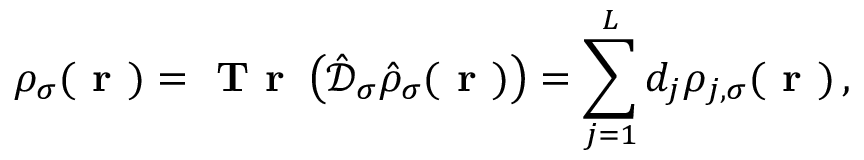<formula> <loc_0><loc_0><loc_500><loc_500>\rho _ { \sigma } ( r ) = T r \left ( \hat { \mathcal { D } } _ { \sigma } \hat { \rho } _ { \sigma } ( r ) \right ) = \sum _ { j = 1 } ^ { L } d _ { j } \rho _ { j , \sigma } ( r ) \, ,</formula> 